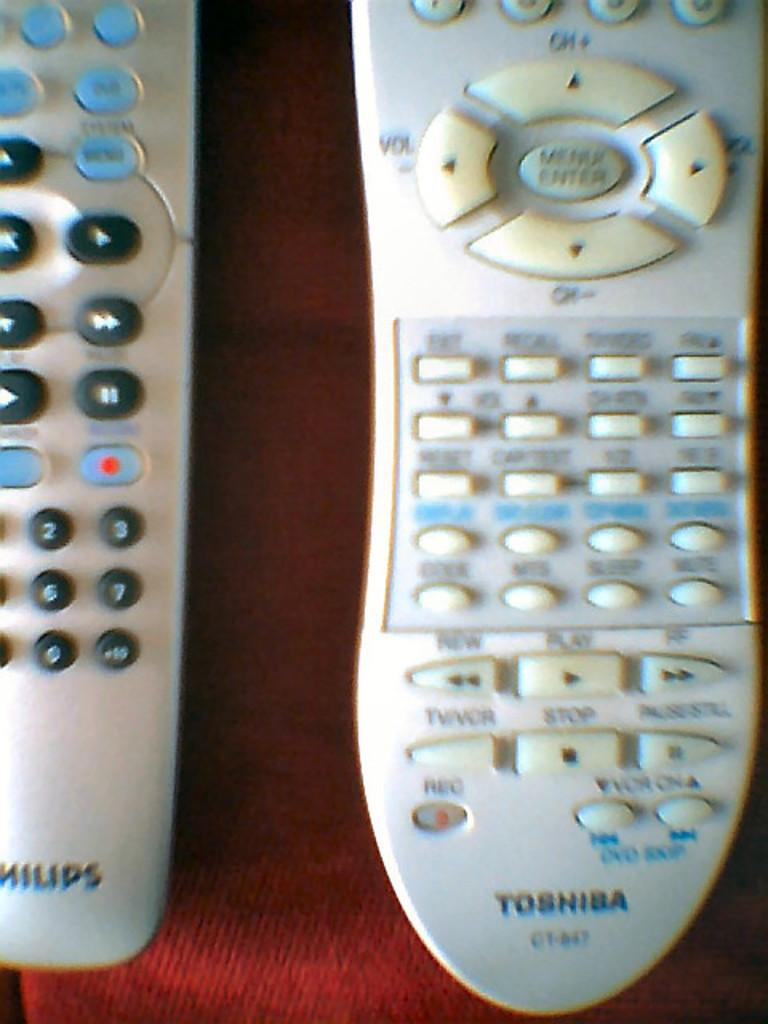Provide a one-sentence caption for the provided image. A Philips and Toshiba white remote beside each other. 